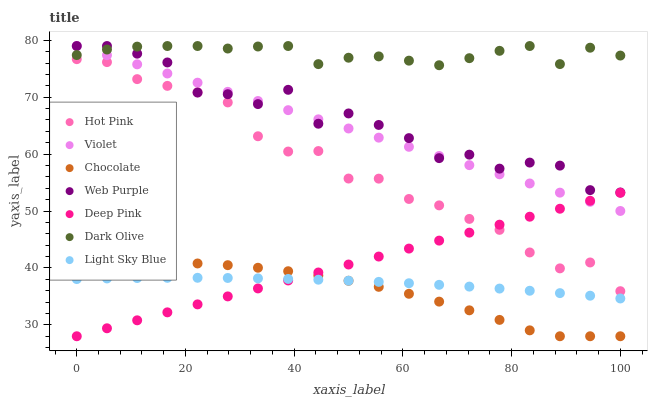Does Chocolate have the minimum area under the curve?
Answer yes or no. Yes. Does Dark Olive have the maximum area under the curve?
Answer yes or no. Yes. Does Dark Olive have the minimum area under the curve?
Answer yes or no. No. Does Chocolate have the maximum area under the curve?
Answer yes or no. No. Is Violet the smoothest?
Answer yes or no. Yes. Is Web Purple the roughest?
Answer yes or no. Yes. Is Dark Olive the smoothest?
Answer yes or no. No. Is Dark Olive the roughest?
Answer yes or no. No. Does Chocolate have the lowest value?
Answer yes or no. Yes. Does Dark Olive have the lowest value?
Answer yes or no. No. Does Violet have the highest value?
Answer yes or no. Yes. Does Chocolate have the highest value?
Answer yes or no. No. Is Deep Pink less than Web Purple?
Answer yes or no. Yes. Is Violet greater than Light Sky Blue?
Answer yes or no. Yes. Does Violet intersect Deep Pink?
Answer yes or no. Yes. Is Violet less than Deep Pink?
Answer yes or no. No. Is Violet greater than Deep Pink?
Answer yes or no. No. Does Deep Pink intersect Web Purple?
Answer yes or no. No. 